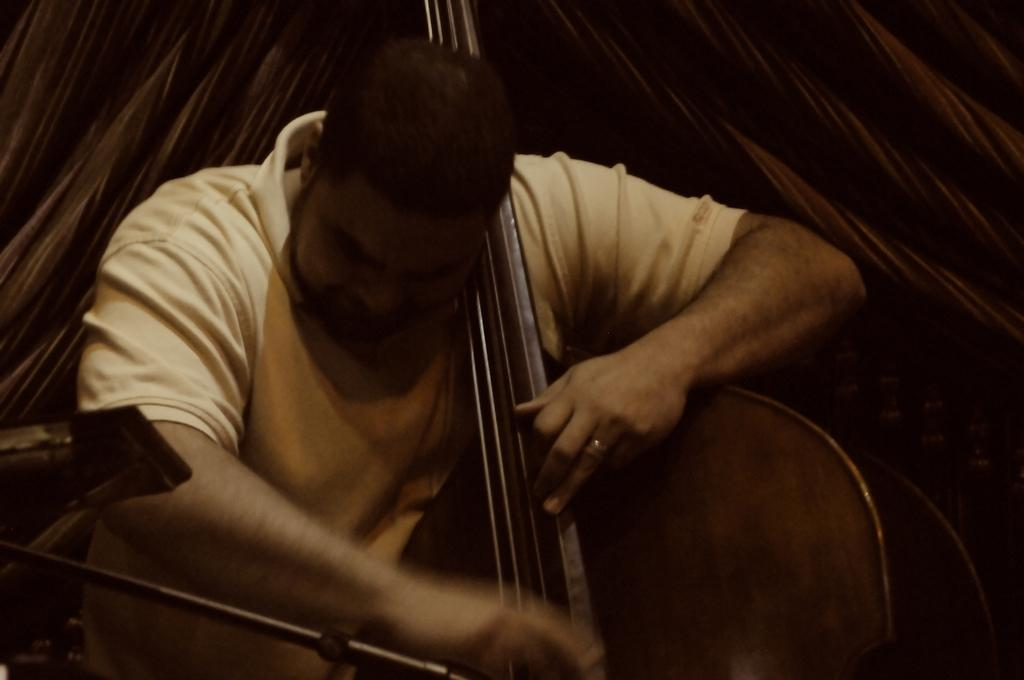What is the main subject of the image? There is a person in the image. What is the person doing in the image? The person is playing a musical instrument. What can be seen in the background of the image? There is a curtain in the background of the image. How many planes are visible in the image? There are no planes visible in the image; it features a person playing a musical instrument with a curtain in the background. Is there a rabbit playing the musical instrument in the image? No, there is no rabbit present in the image; it is a person playing the musical instrument. 